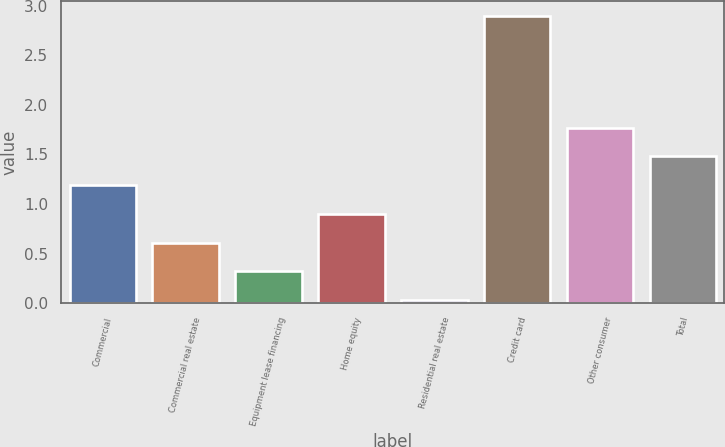Convert chart to OTSL. <chart><loc_0><loc_0><loc_500><loc_500><bar_chart><fcel>Commercial<fcel>Commercial real estate<fcel>Equipment lease financing<fcel>Home equity<fcel>Residential real estate<fcel>Credit card<fcel>Other consumer<fcel>Total<nl><fcel>1.19<fcel>0.61<fcel>0.32<fcel>0.9<fcel>0.03<fcel>2.9<fcel>1.77<fcel>1.48<nl></chart> 